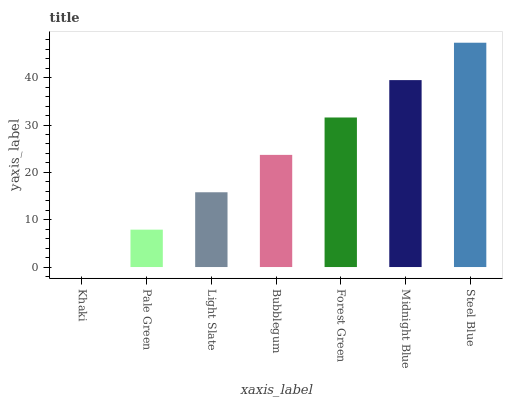Is Khaki the minimum?
Answer yes or no. Yes. Is Steel Blue the maximum?
Answer yes or no. Yes. Is Pale Green the minimum?
Answer yes or no. No. Is Pale Green the maximum?
Answer yes or no. No. Is Pale Green greater than Khaki?
Answer yes or no. Yes. Is Khaki less than Pale Green?
Answer yes or no. Yes. Is Khaki greater than Pale Green?
Answer yes or no. No. Is Pale Green less than Khaki?
Answer yes or no. No. Is Bubblegum the high median?
Answer yes or no. Yes. Is Bubblegum the low median?
Answer yes or no. Yes. Is Khaki the high median?
Answer yes or no. No. Is Pale Green the low median?
Answer yes or no. No. 